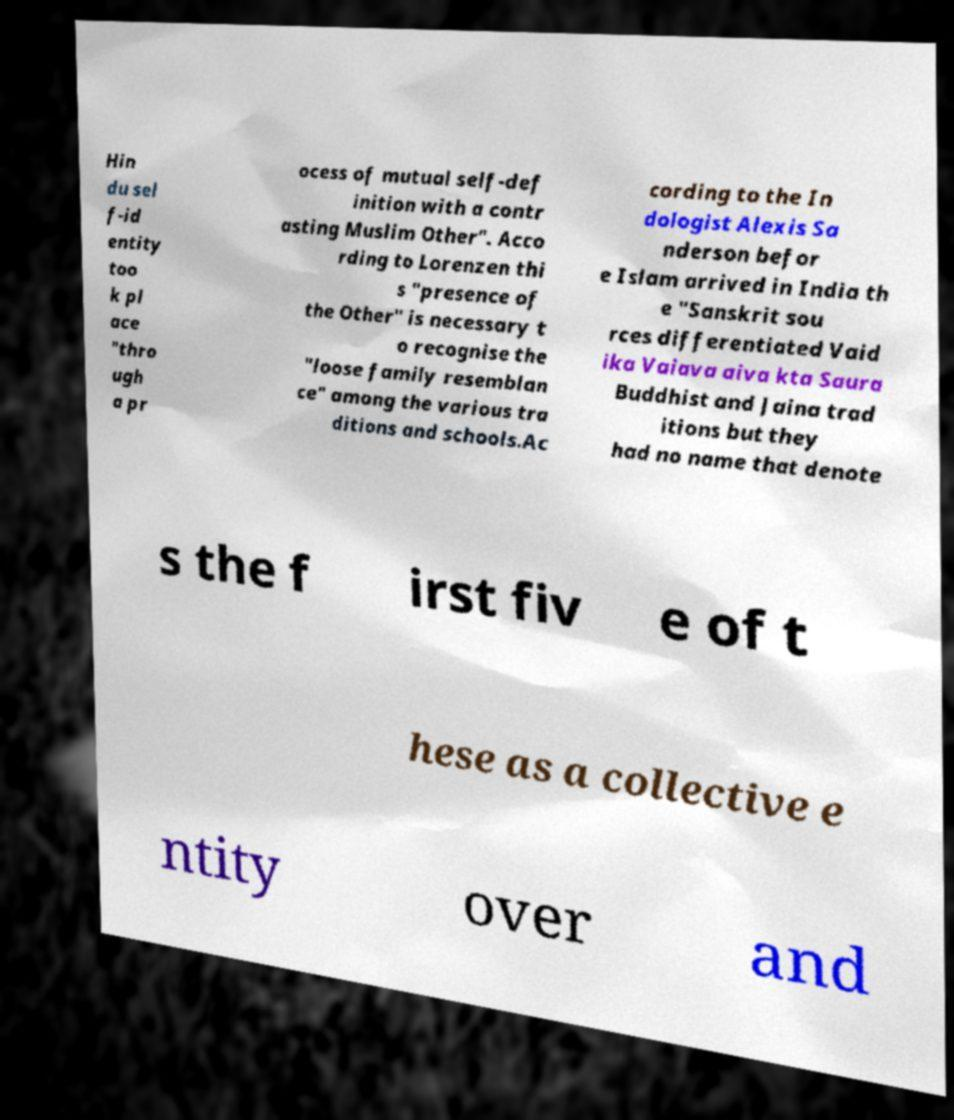Please identify and transcribe the text found in this image. Hin du sel f-id entity too k pl ace "thro ugh a pr ocess of mutual self-def inition with a contr asting Muslim Other". Acco rding to Lorenzen thi s "presence of the Other" is necessary t o recognise the "loose family resemblan ce" among the various tra ditions and schools.Ac cording to the In dologist Alexis Sa nderson befor e Islam arrived in India th e "Sanskrit sou rces differentiated Vaid ika Vaiava aiva kta Saura Buddhist and Jaina trad itions but they had no name that denote s the f irst fiv e of t hese as a collective e ntity over and 